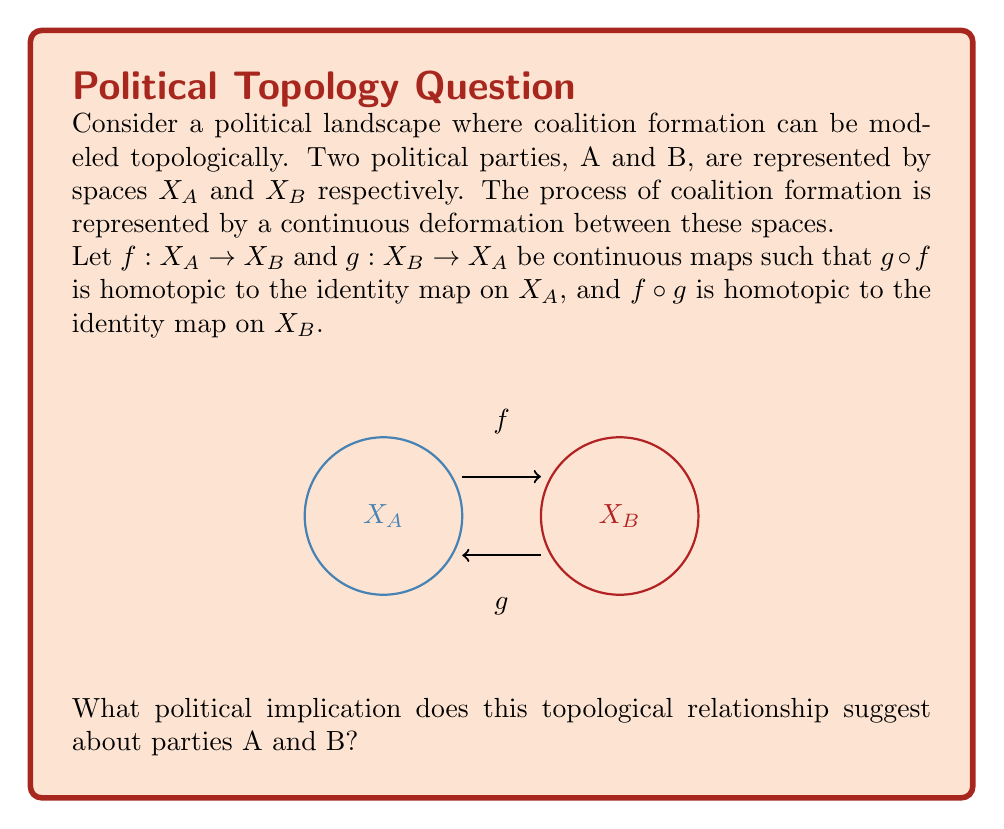Provide a solution to this math problem. To understand the political implication of this topological relationship, let's break down the concept of homotopy equivalence and its application to coalition formation:

1) Homotopy equivalence: The conditions given ($g \circ f \simeq id_{X_A}$ and $f \circ g \simeq id_{X_B}$, where $\simeq$ denotes homotopy) define a homotopy equivalence between spaces $X_A$ and $X_B$. This means that these spaces have the same fundamental topological structure.

2) Political interpretation: In the context of political coalitions, we can interpret this as follows:

   a) The continuous maps $f$ and $g$ represent ways of translating policies or positions from one party to another.
   
   b) The fact that these maps are homotopy inverses of each other suggests that this translation can be done in both directions without losing essential characteristics.

3) Implications:

   a) Structural similarity: The parties, despite potentially having different specific policies, have fundamentally similar structures in terms of their policy spaces or ideological frameworks.
   
   b) Potential for cooperation: The existence of these maps suggests that the parties can find common ground or translate their positions in a way that's mutually understandable and potentially agreeable.
   
   c) Flexibility: The homotopy relation (rather than strict equality) implies that there's some flexibility or room for negotiation in how policies are interpreted or implemented.

4) Coalition formation: In the context of coalition formation, this topological relationship suggests that parties A and B are well-positioned to form a stable coalition. They can effectively communicate their positions to each other and find common ground without either party needing to fundamentally change its core structure or values.

5) Long-term stability: The reciprocal nature of the homotopy equivalence (it works in both directions) suggests that this coalition could be stable over time, with both parties able to maintain their distinct identities while working together effectively.

Therefore, the topological relationship of homotopy equivalence between the spaces representing parties A and B suggests a strong potential for effective and stable coalition formation between these parties.
Answer: Homotopy equivalence implies strong coalition potential with maintained party identities. 